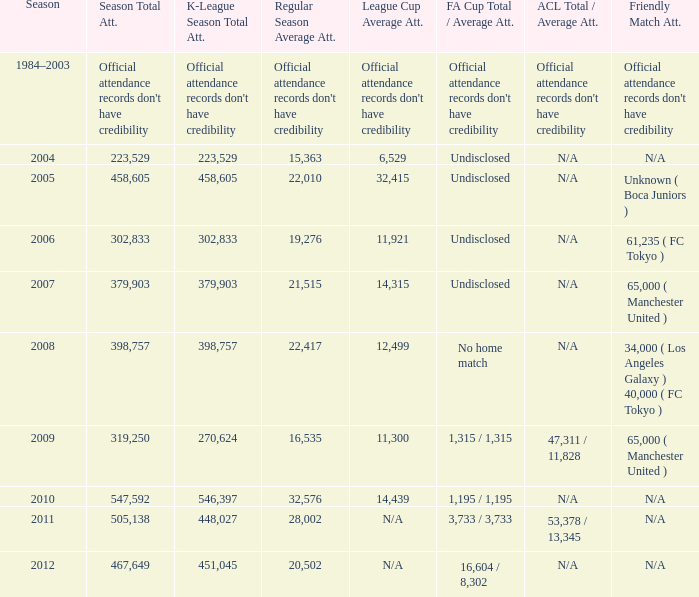What was the cumulative attendance for the full season when the average presence for league cup was 32,415? 458605.0. 